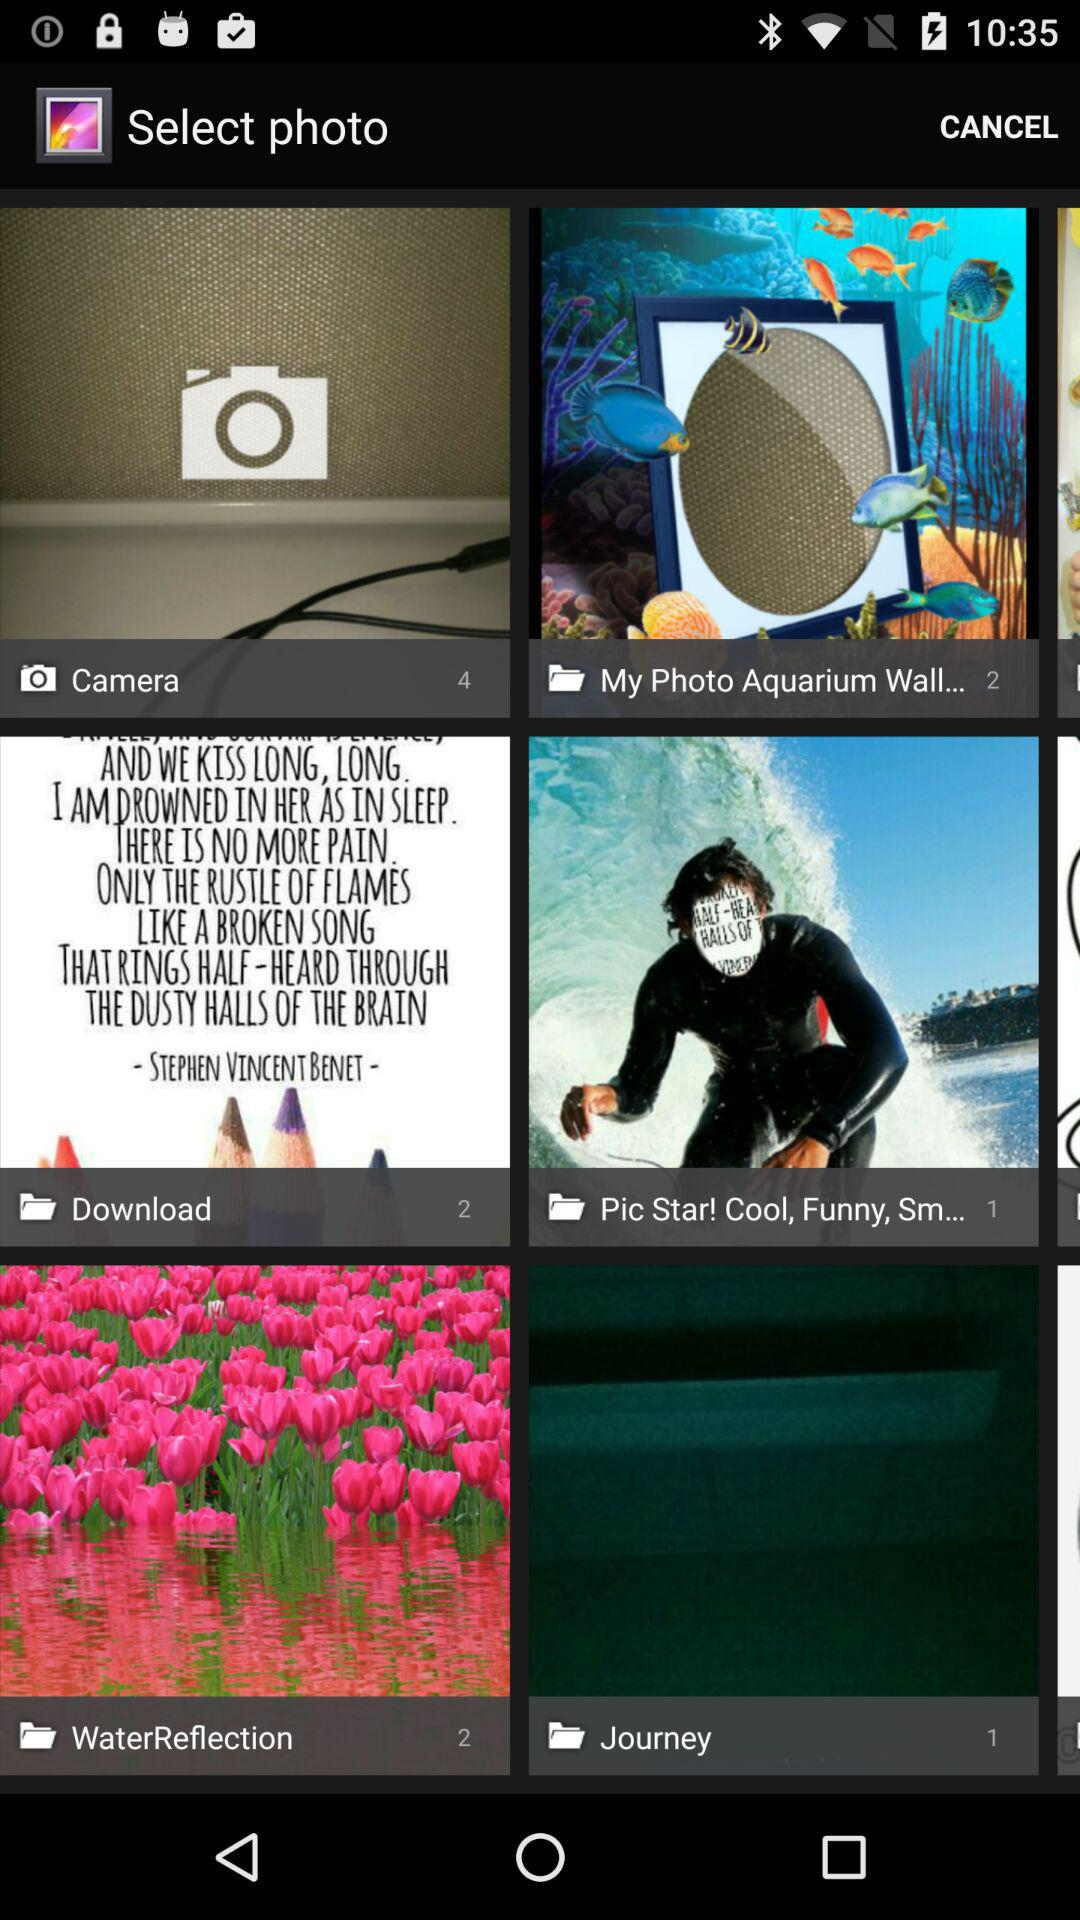How many pictures are available in the camera? The pictures available in the camera are 4. 